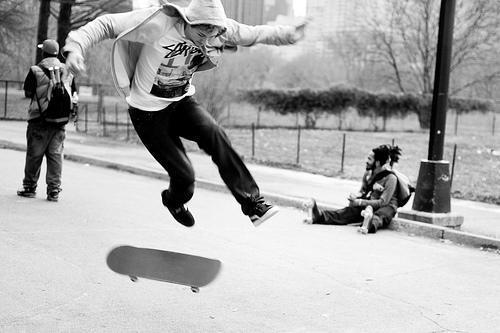How many people are pictured?
Give a very brief answer. 3. 